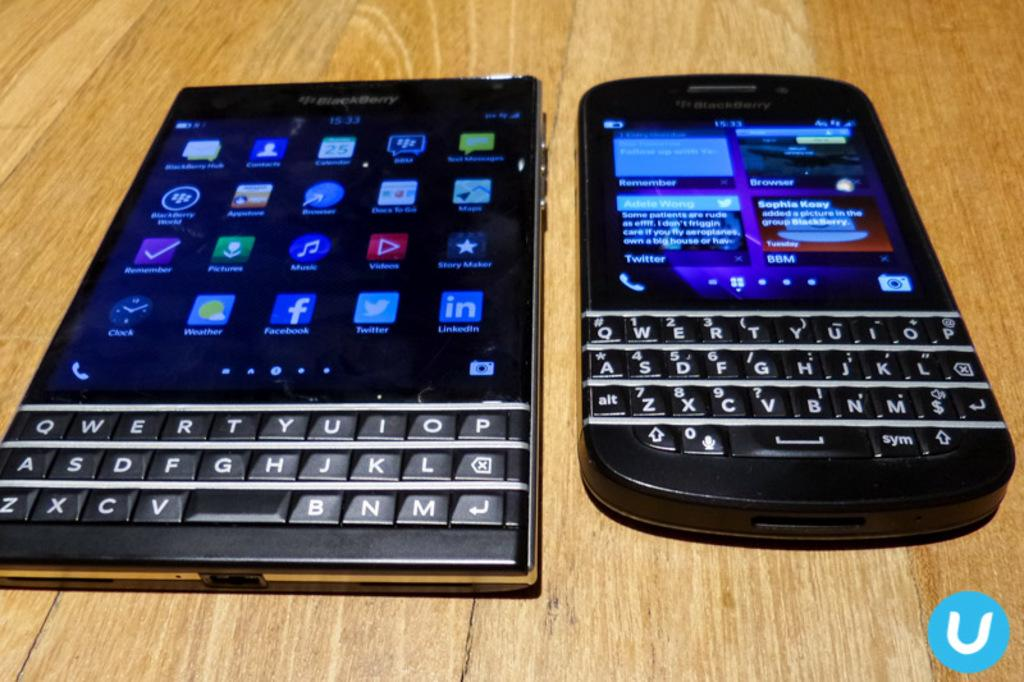Provide a one-sentence caption for the provided image. Two devices, made by Blackberry, sit side by side. 